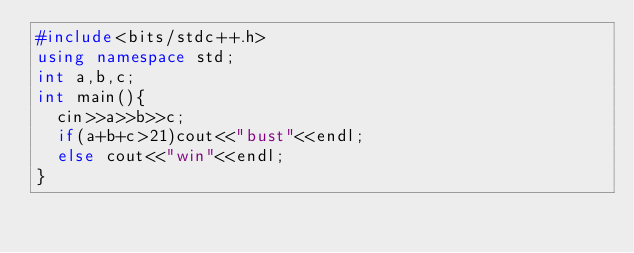<code> <loc_0><loc_0><loc_500><loc_500><_C++_>#include<bits/stdc++.h>
using namespace std;
int a,b,c;
int main(){
  cin>>a>>b>>c;
  if(a+b+c>21)cout<<"bust"<<endl;
  else cout<<"win"<<endl;
}</code> 